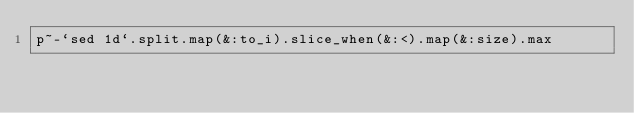Convert code to text. <code><loc_0><loc_0><loc_500><loc_500><_Ruby_>p~-`sed 1d`.split.map(&:to_i).slice_when(&:<).map(&:size).max</code> 